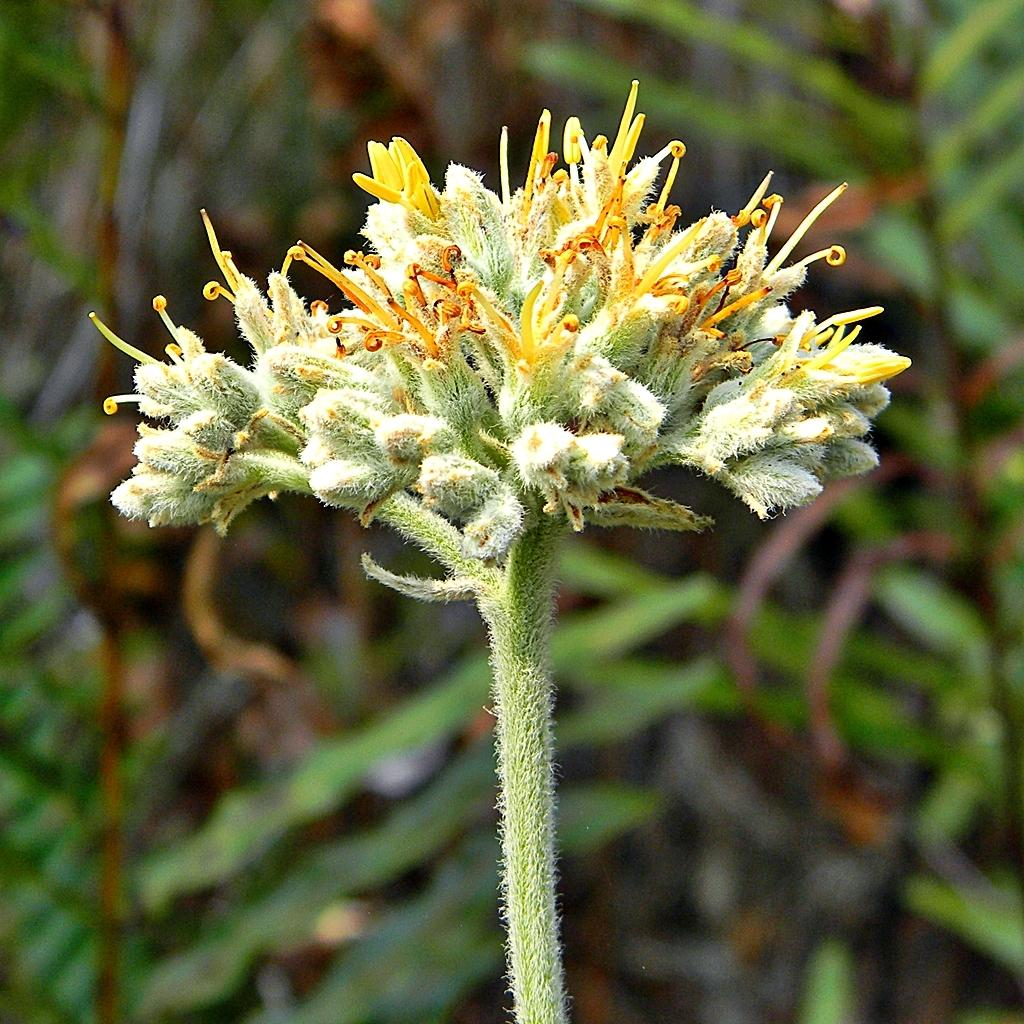What type of flower is present in the image? There is a green color flower in the image. Are there any other colors present in the flowers? Yes, there are yellow color buds in the image. How would you describe the overall clarity of the image? The image is slightly blurry in the background. What type of structure can be seen in the background of the image? There is no structure visible in the background of the image; it is slightly blurry. How many men are present in the image? There are no men present in the image; it features flowers. 